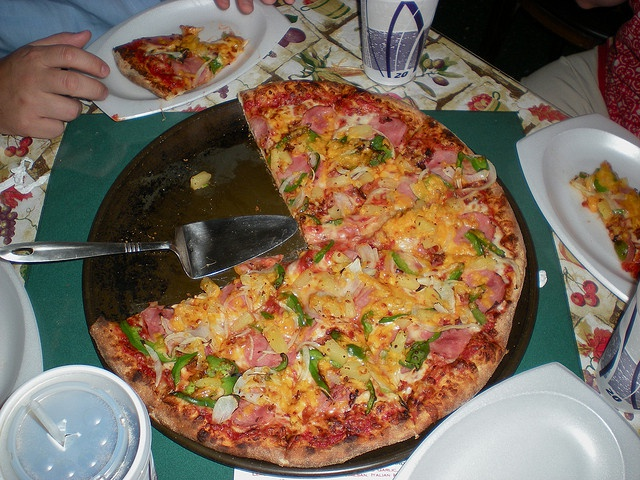Describe the objects in this image and their specific colors. I can see dining table in black, darkgray, blue, brown, and tan tones, pizza in blue, brown, and tan tones, cup in blue, darkgray, lightblue, and lightgray tones, people in blue, gray, and brown tones, and people in blue, gray, black, and maroon tones in this image. 